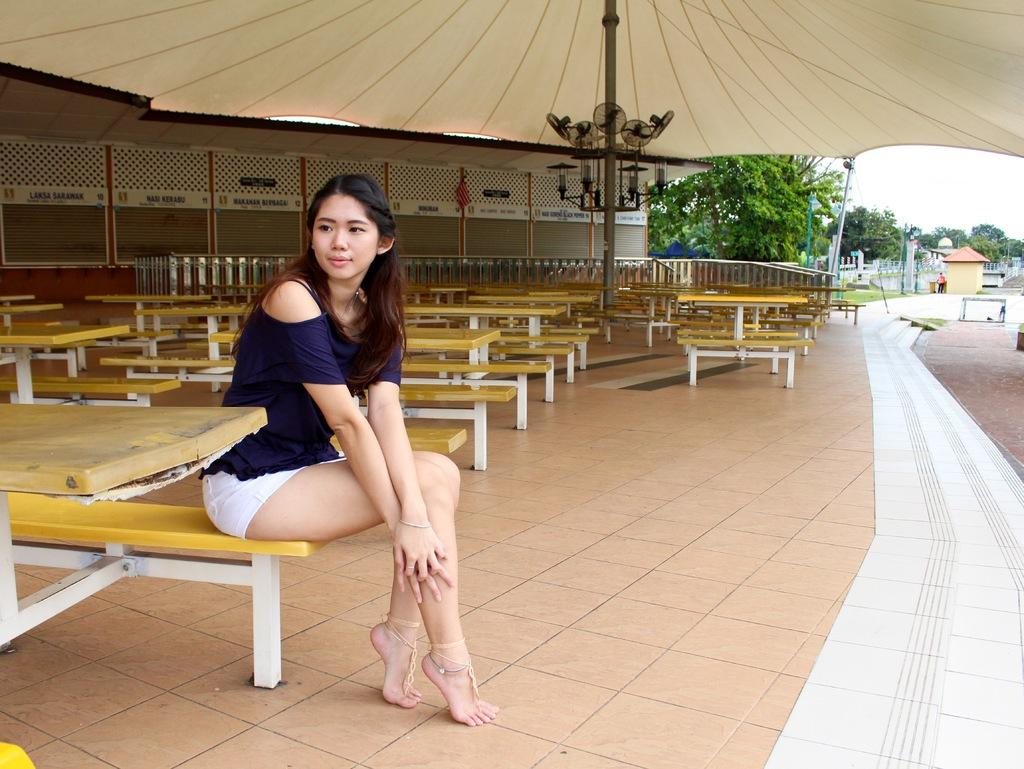Who is the main subject in the image? There is a woman in the image. What is the woman doing in the image? The woman is sitting on a chair. Where is the woman located in the image? The woman is on the left side of the image. What can be seen in the background of the image? There are tables and a tree in the background of the image. What type of cushion is the woman sitting on in the image? There is no mention of a cushion in the image; the woman is sitting on a chair. 